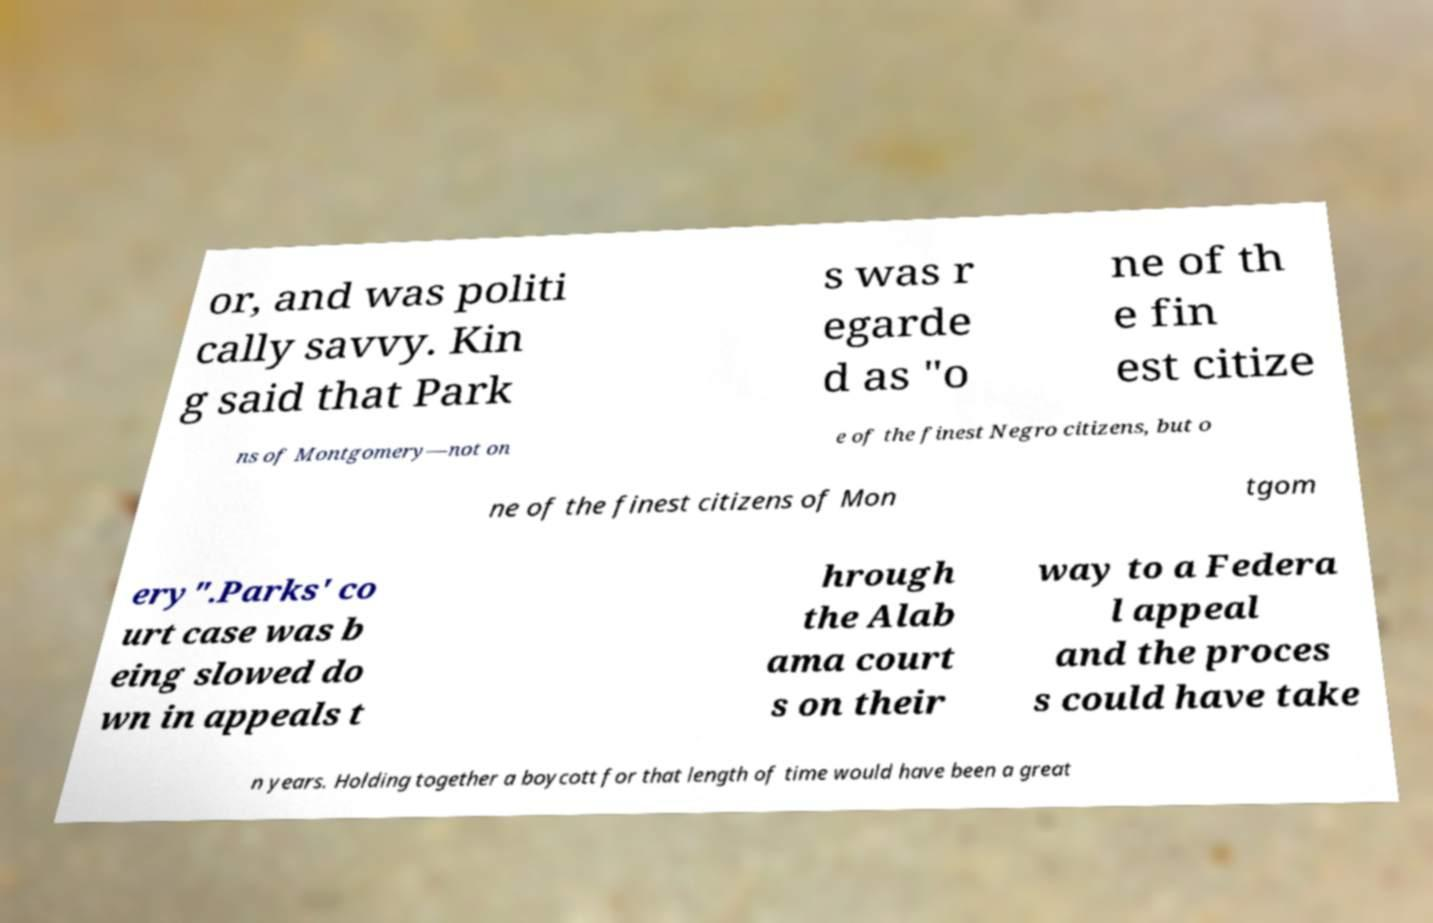What messages or text are displayed in this image? I need them in a readable, typed format. or, and was politi cally savvy. Kin g said that Park s was r egarde d as "o ne of th e fin est citize ns of Montgomery—not on e of the finest Negro citizens, but o ne of the finest citizens of Mon tgom ery".Parks' co urt case was b eing slowed do wn in appeals t hrough the Alab ama court s on their way to a Federa l appeal and the proces s could have take n years. Holding together a boycott for that length of time would have been a great 